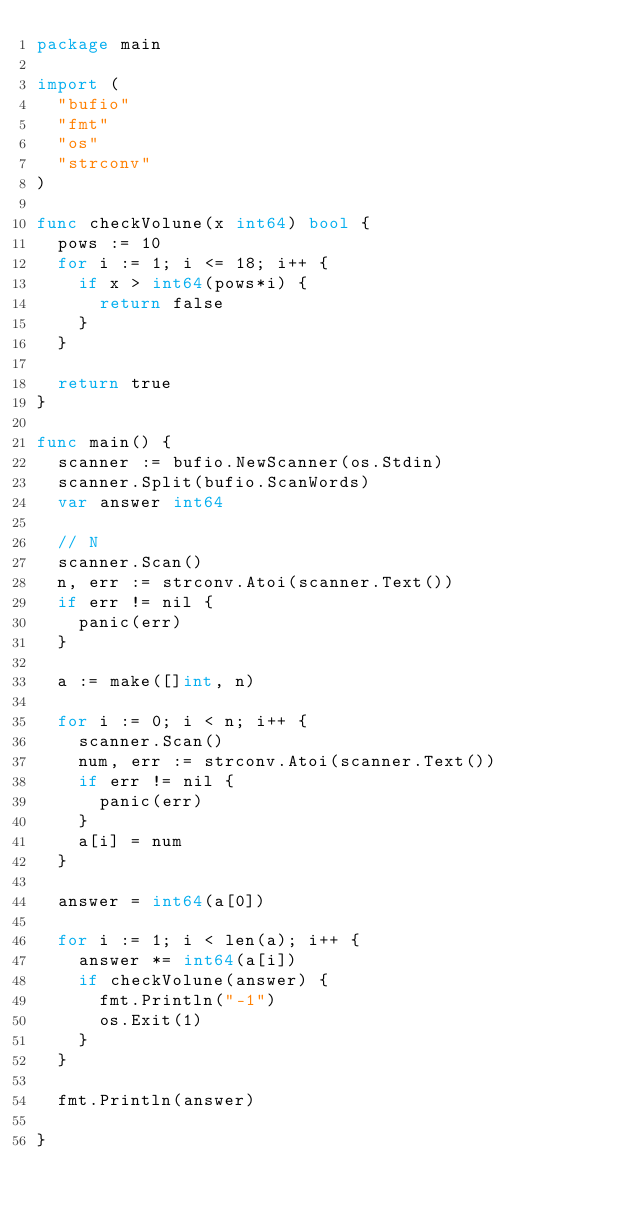<code> <loc_0><loc_0><loc_500><loc_500><_Go_>package main

import (
	"bufio"
	"fmt"
	"os"
	"strconv"
)

func checkVolune(x int64) bool {
	pows := 10
	for i := 1; i <= 18; i++ {
		if x > int64(pows*i) {
			return false
		}
	}

	return true
}

func main() {
	scanner := bufio.NewScanner(os.Stdin)
	scanner.Split(bufio.ScanWords)
	var answer int64

	// N
	scanner.Scan()
	n, err := strconv.Atoi(scanner.Text())
	if err != nil {
		panic(err)
	}

	a := make([]int, n)

	for i := 0; i < n; i++ {
		scanner.Scan()
		num, err := strconv.Atoi(scanner.Text())
		if err != nil {
			panic(err)
		}
		a[i] = num
	}

	answer = int64(a[0])

	for i := 1; i < len(a); i++ {
		answer *= int64(a[i])
		if checkVolune(answer) {
			fmt.Println("-1")
			os.Exit(1)
		}
	}

	fmt.Println(answer)

}
</code> 